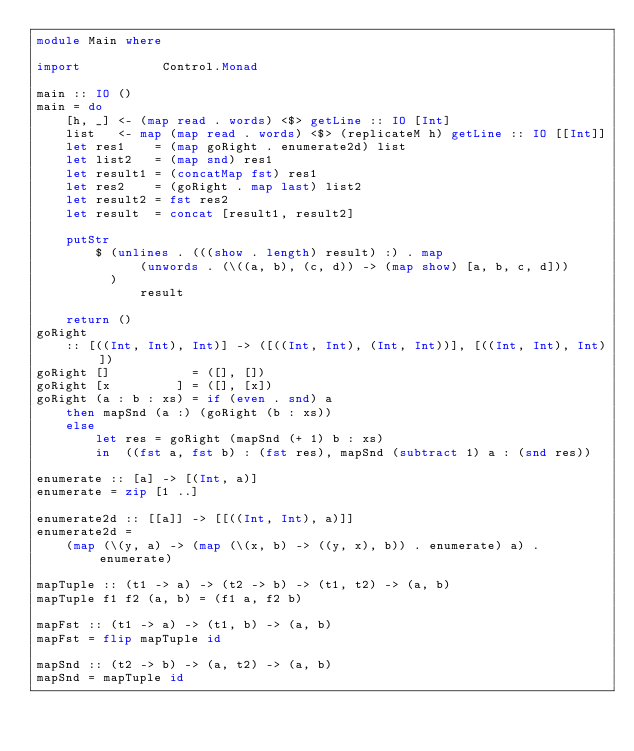Convert code to text. <code><loc_0><loc_0><loc_500><loc_500><_Haskell_>module Main where

import           Control.Monad

main :: IO ()
main = do
    [h, _] <- (map read . words) <$> getLine :: IO [Int]
    list   <- map (map read . words) <$> (replicateM h) getLine :: IO [[Int]]
    let res1    = (map goRight . enumerate2d) list
    let list2   = (map snd) res1
    let result1 = (concatMap fst) res1
    let res2    = (goRight . map last) list2
    let result2 = fst res2
    let result  = concat [result1, result2]

    putStr
        $ (unlines . (((show . length) result) :) . map
              (unwords . (\((a, b), (c, d)) -> (map show) [a, b, c, d]))
          )
              result

    return ()
goRight
    :: [((Int, Int), Int)] -> ([((Int, Int), (Int, Int))], [((Int, Int), Int)])
goRight []           = ([], [])
goRight [x         ] = ([], [x])
goRight (a : b : xs) = if (even . snd) a
    then mapSnd (a :) (goRight (b : xs))
    else
        let res = goRight (mapSnd (+ 1) b : xs)
        in  ((fst a, fst b) : (fst res), mapSnd (subtract 1) a : (snd res))

enumerate :: [a] -> [(Int, a)]
enumerate = zip [1 ..]

enumerate2d :: [[a]] -> [[((Int, Int), a)]]
enumerate2d =
    (map (\(y, a) -> (map (\(x, b) -> ((y, x), b)) . enumerate) a) . enumerate)

mapTuple :: (t1 -> a) -> (t2 -> b) -> (t1, t2) -> (a, b)
mapTuple f1 f2 (a, b) = (f1 a, f2 b)

mapFst :: (t1 -> a) -> (t1, b) -> (a, b)
mapFst = flip mapTuple id

mapSnd :: (t2 -> b) -> (a, t2) -> (a, b)
mapSnd = mapTuple id
</code> 